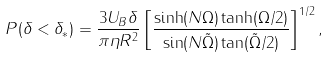<formula> <loc_0><loc_0><loc_500><loc_500>P ( \delta < \delta _ { * } ) = \frac { 3 U _ { B } \delta } { \pi \eta R ^ { 2 } } \left [ \frac { \sinh ( N \Omega ) \tanh ( \Omega / 2 ) } { \sin ( N { \tilde { \Omega } } ) \tan ( { \tilde { \Omega } } / 2 ) } \right ] ^ { 1 / 2 } ,</formula> 